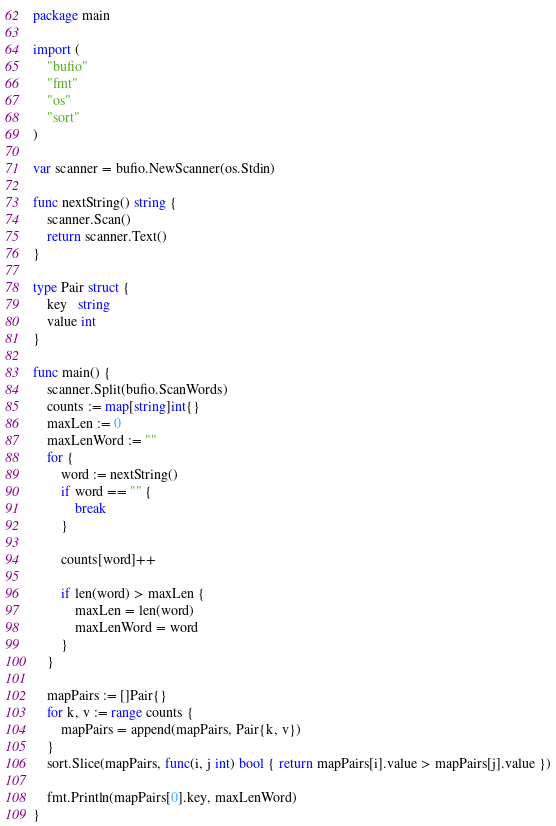Convert code to text. <code><loc_0><loc_0><loc_500><loc_500><_Go_>package main

import (
	"bufio"
	"fmt"
	"os"
	"sort"
)

var scanner = bufio.NewScanner(os.Stdin)

func nextString() string {
	scanner.Scan()
	return scanner.Text()
}

type Pair struct {
	key   string
	value int
}

func main() {
	scanner.Split(bufio.ScanWords)
	counts := map[string]int{}
	maxLen := 0
	maxLenWord := ""
	for {
		word := nextString()
		if word == "" {
			break
		}

		counts[word]++

		if len(word) > maxLen {
			maxLen = len(word)
			maxLenWord = word
		}
	}

	mapPairs := []Pair{}
	for k, v := range counts {
		mapPairs = append(mapPairs, Pair{k, v})
	}
	sort.Slice(mapPairs, func(i, j int) bool { return mapPairs[i].value > mapPairs[j].value })

	fmt.Println(mapPairs[0].key, maxLenWord)
}

</code> 